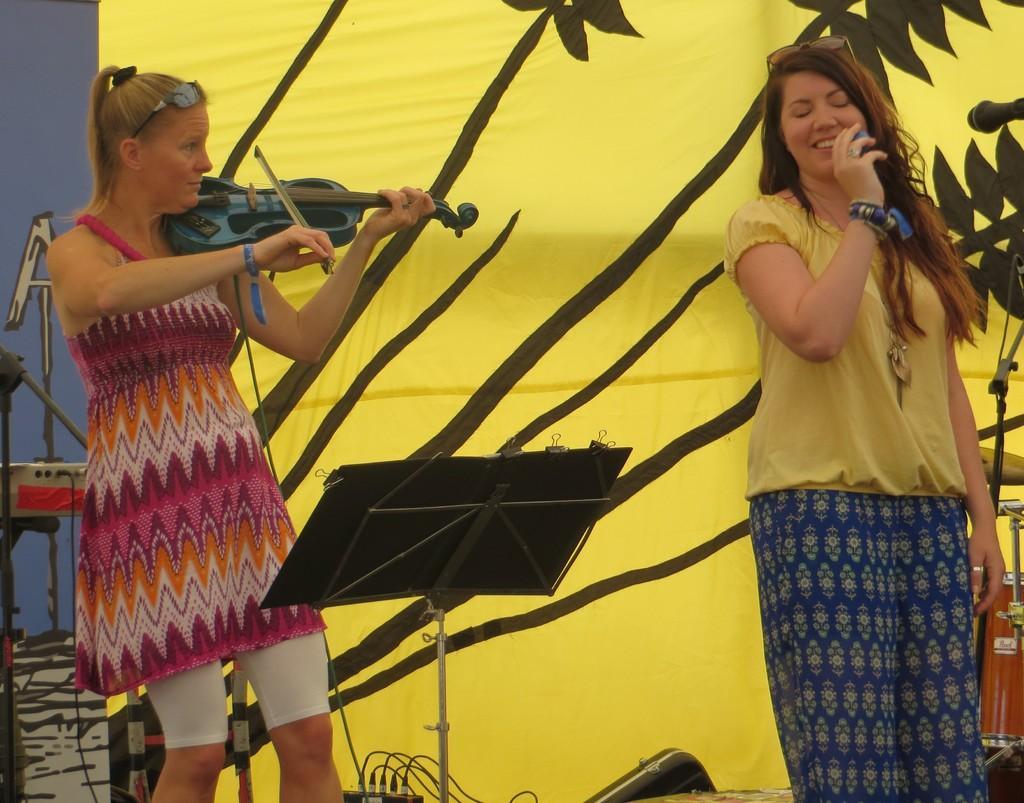How would you summarize this image in a sentence or two? In this picture we can see two women on a platform. One women is playing a violin and at the right side of the picture we can see a woman standing and smiling. This is a table. On the background it is decorated with yellow and black colour cloth. This is a mike. 